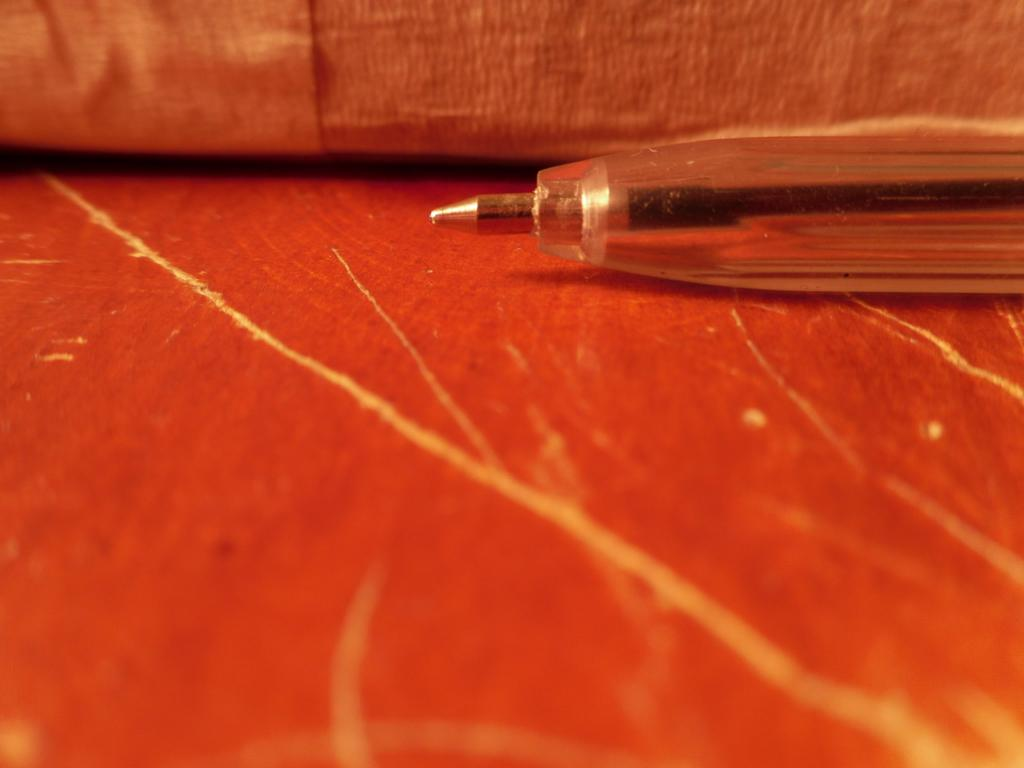What stationary item can be seen in the image? There is a pen in the image. On which side of the image is the pen located? The pen is on the right side of the image. What type of material is used to make the wooden object in the image? The wooden object in the image is made of wood. Where is the wooden object located in the image? The wooden object is at the bottom of the image. What other object can be seen in the image? There is an object in the image. Where is this object located in the image? The object is at the top of the image. How many eggs are being treated by the ants in the image? There are no ants or eggs present in the image. 